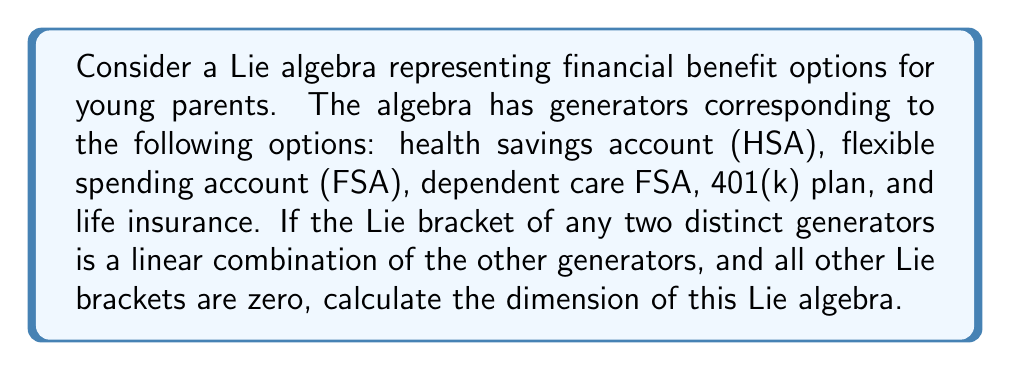Solve this math problem. To calculate the dimension of this Lie algebra, we need to follow these steps:

1) First, let's identify the generators:
   $g_1$ = HSA
   $g_2$ = FSA
   $g_3$ = Dependent care FSA
   $g_4$ = 401(k) plan
   $g_5$ = Life insurance

2) The dimension of a Lie algebra is equal to the number of linearly independent elements in its basis. In this case, we start with 5 generators.

3) We need to consider the Lie brackets of these generators. The question states that the Lie bracket of any two distinct generators is a linear combination of the other generators. This means:

   $[g_i, g_j] = \sum_{k \neq i,j} c_k g_k$ for some constants $c_k$, where $i \neq j$

4) However, we're also told that all other Lie brackets are zero. This implies that the Lie brackets mentioned in step 3 are actually zero as well, because they're linear combinations of generators that aren't involved in the bracket.

5) In other words, we have:

   $[g_i, g_j] = 0$ for all $i, j$

6) This means we have a trivial Lie algebra, where all Lie brackets are zero. In such a case, the generators form a basis for the Lie algebra.

7) Therefore, the dimension of the Lie algebra is equal to the number of generators.
Answer: The dimension of the Lie algebra is 5. 